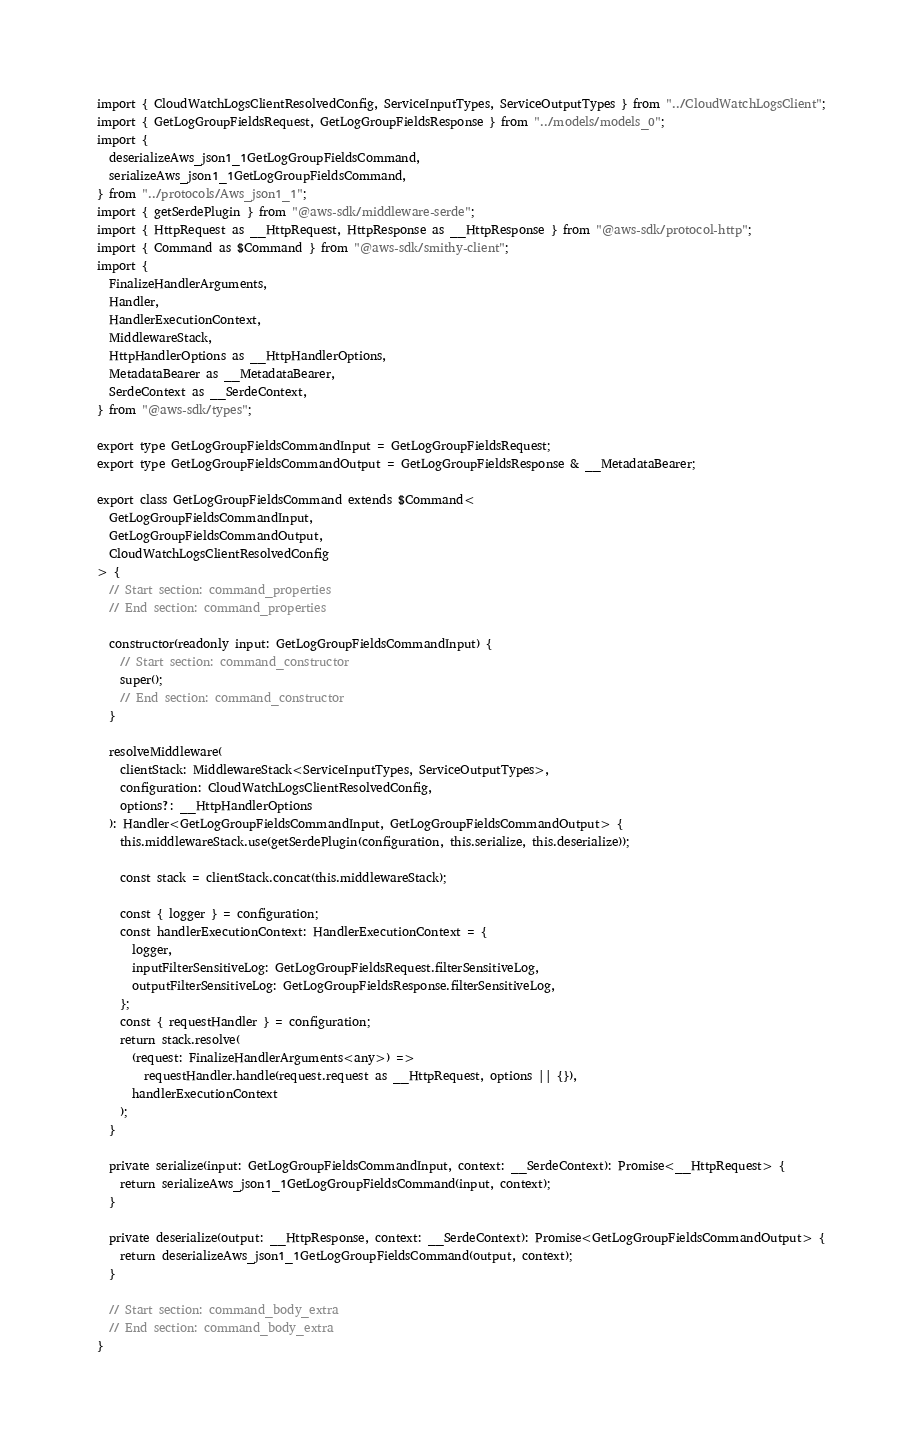<code> <loc_0><loc_0><loc_500><loc_500><_TypeScript_>import { CloudWatchLogsClientResolvedConfig, ServiceInputTypes, ServiceOutputTypes } from "../CloudWatchLogsClient";
import { GetLogGroupFieldsRequest, GetLogGroupFieldsResponse } from "../models/models_0";
import {
  deserializeAws_json1_1GetLogGroupFieldsCommand,
  serializeAws_json1_1GetLogGroupFieldsCommand,
} from "../protocols/Aws_json1_1";
import { getSerdePlugin } from "@aws-sdk/middleware-serde";
import { HttpRequest as __HttpRequest, HttpResponse as __HttpResponse } from "@aws-sdk/protocol-http";
import { Command as $Command } from "@aws-sdk/smithy-client";
import {
  FinalizeHandlerArguments,
  Handler,
  HandlerExecutionContext,
  MiddlewareStack,
  HttpHandlerOptions as __HttpHandlerOptions,
  MetadataBearer as __MetadataBearer,
  SerdeContext as __SerdeContext,
} from "@aws-sdk/types";

export type GetLogGroupFieldsCommandInput = GetLogGroupFieldsRequest;
export type GetLogGroupFieldsCommandOutput = GetLogGroupFieldsResponse & __MetadataBearer;

export class GetLogGroupFieldsCommand extends $Command<
  GetLogGroupFieldsCommandInput,
  GetLogGroupFieldsCommandOutput,
  CloudWatchLogsClientResolvedConfig
> {
  // Start section: command_properties
  // End section: command_properties

  constructor(readonly input: GetLogGroupFieldsCommandInput) {
    // Start section: command_constructor
    super();
    // End section: command_constructor
  }

  resolveMiddleware(
    clientStack: MiddlewareStack<ServiceInputTypes, ServiceOutputTypes>,
    configuration: CloudWatchLogsClientResolvedConfig,
    options?: __HttpHandlerOptions
  ): Handler<GetLogGroupFieldsCommandInput, GetLogGroupFieldsCommandOutput> {
    this.middlewareStack.use(getSerdePlugin(configuration, this.serialize, this.deserialize));

    const stack = clientStack.concat(this.middlewareStack);

    const { logger } = configuration;
    const handlerExecutionContext: HandlerExecutionContext = {
      logger,
      inputFilterSensitiveLog: GetLogGroupFieldsRequest.filterSensitiveLog,
      outputFilterSensitiveLog: GetLogGroupFieldsResponse.filterSensitiveLog,
    };
    const { requestHandler } = configuration;
    return stack.resolve(
      (request: FinalizeHandlerArguments<any>) =>
        requestHandler.handle(request.request as __HttpRequest, options || {}),
      handlerExecutionContext
    );
  }

  private serialize(input: GetLogGroupFieldsCommandInput, context: __SerdeContext): Promise<__HttpRequest> {
    return serializeAws_json1_1GetLogGroupFieldsCommand(input, context);
  }

  private deserialize(output: __HttpResponse, context: __SerdeContext): Promise<GetLogGroupFieldsCommandOutput> {
    return deserializeAws_json1_1GetLogGroupFieldsCommand(output, context);
  }

  // Start section: command_body_extra
  // End section: command_body_extra
}
</code> 